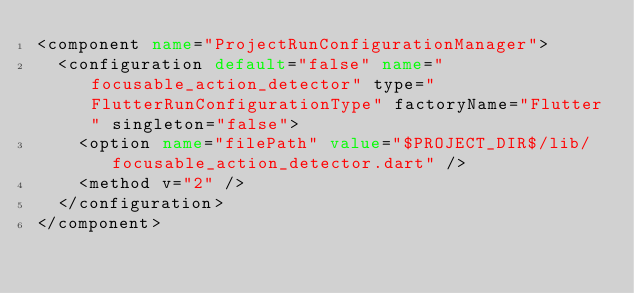Convert code to text. <code><loc_0><loc_0><loc_500><loc_500><_XML_><component name="ProjectRunConfigurationManager">
  <configuration default="false" name="focusable_action_detector" type="FlutterRunConfigurationType" factoryName="Flutter" singleton="false">
    <option name="filePath" value="$PROJECT_DIR$/lib/focusable_action_detector.dart" />
    <method v="2" />
  </configuration>
</component></code> 